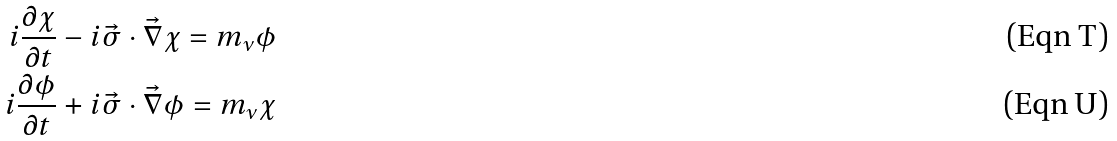<formula> <loc_0><loc_0><loc_500><loc_500>i \frac { \partial \chi } { \partial t } - i \vec { \sigma } \cdot \vec { \nabla } \chi = m _ { \nu } \phi \\ i \frac { \partial \phi } { \partial t } + i \vec { \sigma } \cdot \vec { \nabla } \phi = m _ { \nu } \chi</formula> 